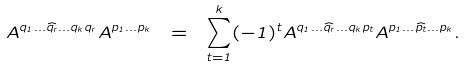Convert formula to latex. <formula><loc_0><loc_0><loc_500><loc_500>A ^ { q _ { 1 } \dots \widehat { q _ { r } } \dots q _ { k } q _ { r } } A ^ { p _ { 1 } \dots p _ { k } } \ = \ \sum _ { t = 1 } ^ { k } ( - 1 ) ^ { t } A ^ { q _ { 1 } \dots \widehat { q _ { r } } \dots q _ { k } p _ { t } } A ^ { p _ { 1 } \dots \widehat { p _ { t } } \dots p _ { k } } .</formula> 